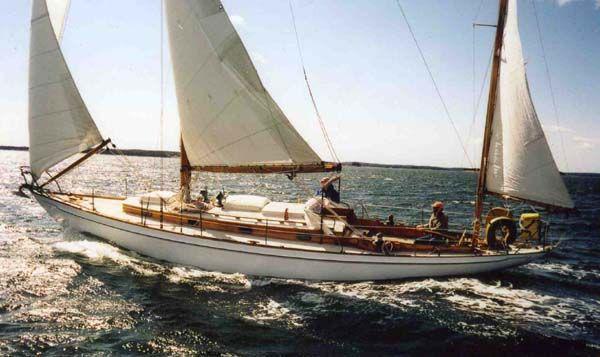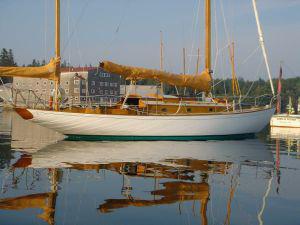The first image is the image on the left, the second image is the image on the right. For the images displayed, is the sentence "People are sailing." factually correct? Answer yes or no. Yes. 